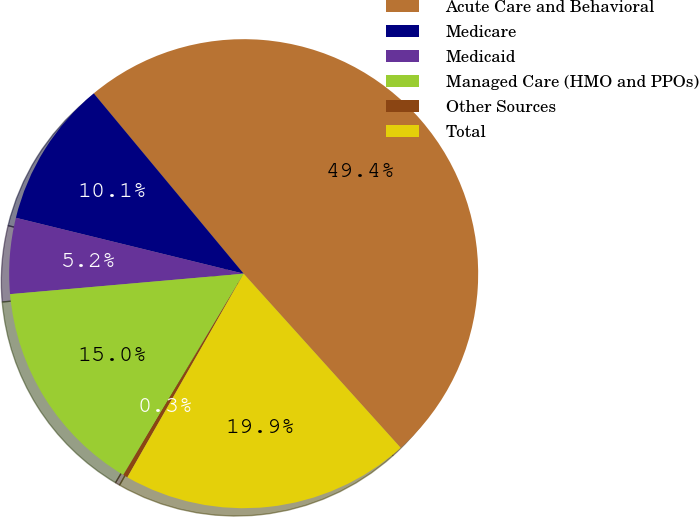Convert chart to OTSL. <chart><loc_0><loc_0><loc_500><loc_500><pie_chart><fcel>Acute Care and Behavioral<fcel>Medicare<fcel>Medicaid<fcel>Managed Care (HMO and PPOs)<fcel>Other Sources<fcel>Total<nl><fcel>49.36%<fcel>10.13%<fcel>5.22%<fcel>15.03%<fcel>0.32%<fcel>19.94%<nl></chart> 